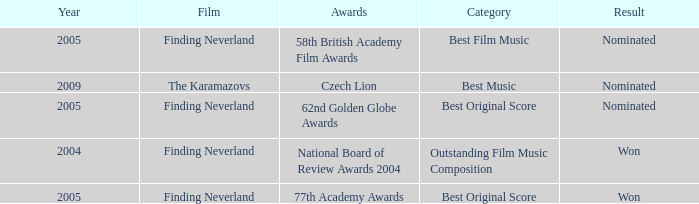How many years were there for the 62nd golden globe awards? 2005.0. 